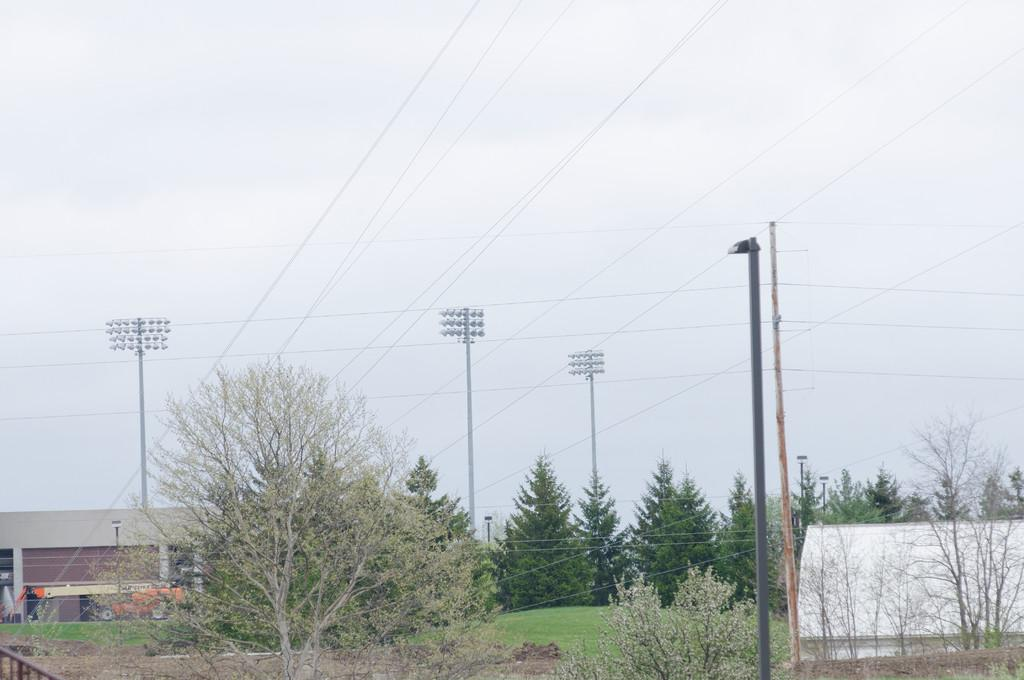What type of vegetation can be seen in the image? There are trees in the image. What structure is located near the trees? There is a shed in the image. What is parked in front of the shed? A vehicle is present in front of the shed. What can be seen in the back of the image? There are many poles and the sky is visible in the back of the image. What type of music can be heard playing from the trees in the image? There is no music present in the image; it only features trees, a shed, a vehicle, poles, and the sky. What type of event is taking place in the image? There is no event taking place in the image; it is a static scene featuring trees, a shed, a vehicle, poles, and the sky. 